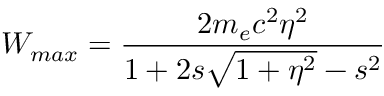<formula> <loc_0><loc_0><loc_500><loc_500>W _ { \max } = \frac { 2 m _ { e } c ^ { 2 } \eta ^ { 2 } } { 1 + 2 s \sqrt { 1 + \eta ^ { 2 } } - s ^ { 2 } }</formula> 